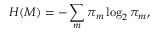Convert formula to latex. <formula><loc_0><loc_0><loc_500><loc_500>H ( M ) = - \sum _ { m } \pi _ { m } \log _ { 2 } \pi _ { m } ,</formula> 